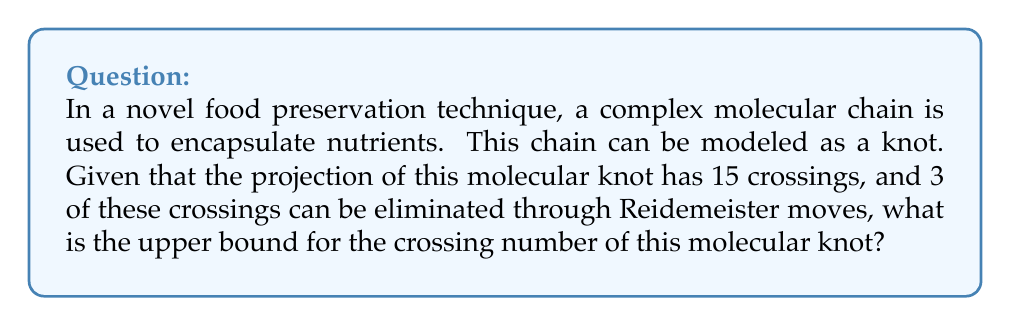Can you answer this question? Let's approach this step-by-step:

1) First, we need to understand what the crossing number represents. The crossing number of a knot is the minimum number of crossings that occur in any projection of the knot.

2) We're given a projection with 15 crossings, but this may not be the minimal projection.

3) We're also told that 3 of these crossings can be eliminated through Reidemeister moves. Reidemeister moves are ways to manipulate a knot diagram without changing the knot type.

4) The number of crossings after these moves would be:

   $$15 - 3 = 12$$

5) This gives us an upper bound for the crossing number. The actual crossing number could be less than or equal to this, but it cannot be more.

6) In knot theory, we denote the crossing number of a knot $K$ as $c(K)$.

7) Therefore, we can express our conclusion as:

   $$c(K) \leq 12$$

where $K$ represents our molecular knot.
Answer: $c(K) \leq 12$ 